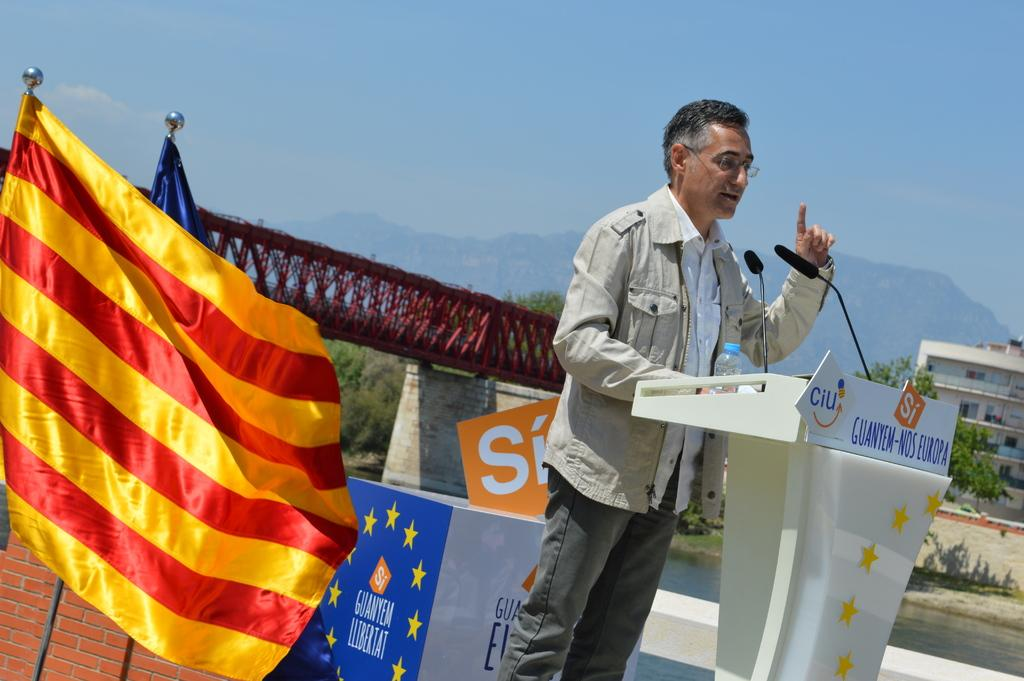What is the man in the image doing? The man is talking on a mic in the image. What can be seen in the image besides the man? There are flags, a poster, a bridge, trees, a building, and hills visible in the background of the image. What is the sky's condition in the image? The sky is visible at the top of the image. How does the man wash his hands while talking on the mic in the image? There is no indication in the image that the man is washing his hands or that there is a wash station present. 